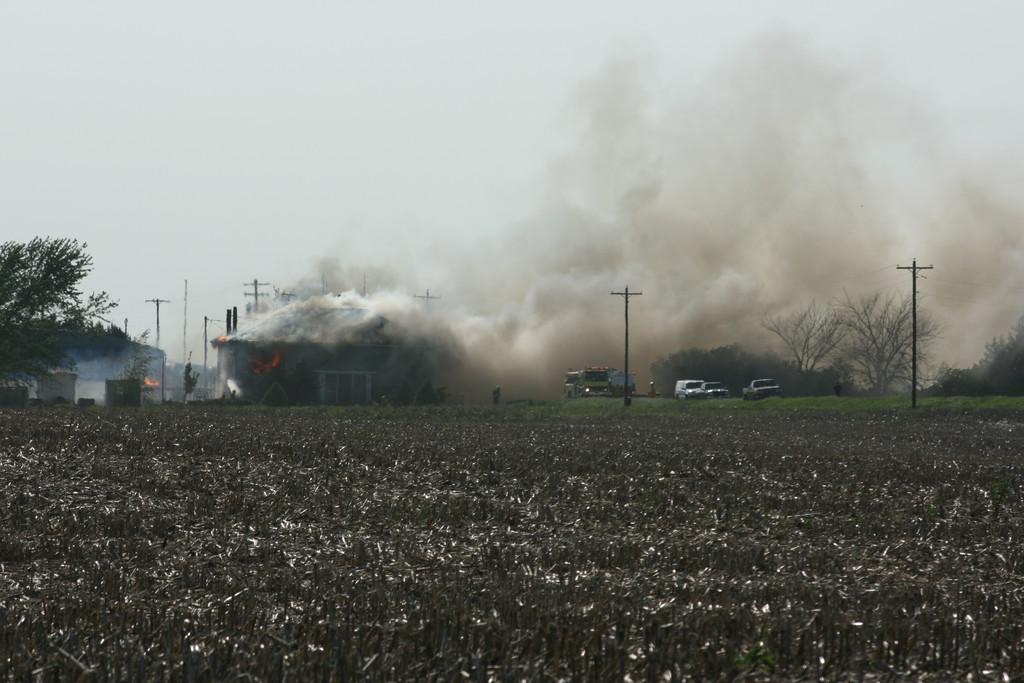What type of vegetation is present on the ground in the center of the image? There is dry grass on the ground in the center of the image. What can be seen in the background of the image? In the background of the image, there are cars, poles, and trees. What is the condition of the sky in the image? The sky is cloudy in the image. Is there any visible evidence of activity in the image? Yes, there is smoke visible in the image. What type of card is being used to play a game in the image? There is no card or game present in the image; it features dry grass, cars, poles, trees, smoke, and a cloudy sky. 